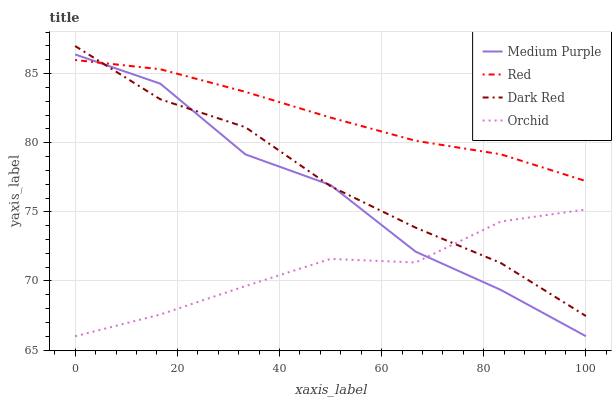Does Orchid have the minimum area under the curve?
Answer yes or no. Yes. Does Red have the maximum area under the curve?
Answer yes or no. Yes. Does Dark Red have the minimum area under the curve?
Answer yes or no. No. Does Dark Red have the maximum area under the curve?
Answer yes or no. No. Is Red the smoothest?
Answer yes or no. Yes. Is Medium Purple the roughest?
Answer yes or no. Yes. Is Dark Red the smoothest?
Answer yes or no. No. Is Dark Red the roughest?
Answer yes or no. No. Does Medium Purple have the lowest value?
Answer yes or no. Yes. Does Dark Red have the lowest value?
Answer yes or no. No. Does Dark Red have the highest value?
Answer yes or no. Yes. Does Red have the highest value?
Answer yes or no. No. Is Orchid less than Red?
Answer yes or no. Yes. Is Red greater than Orchid?
Answer yes or no. Yes. Does Dark Red intersect Red?
Answer yes or no. Yes. Is Dark Red less than Red?
Answer yes or no. No. Is Dark Red greater than Red?
Answer yes or no. No. Does Orchid intersect Red?
Answer yes or no. No. 